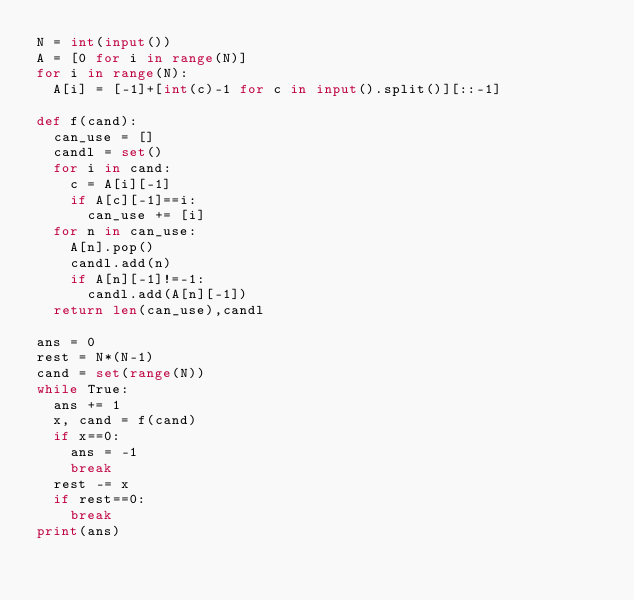<code> <loc_0><loc_0><loc_500><loc_500><_Python_>N = int(input())
A = [0 for i in range(N)]
for i in range(N):
  A[i] = [-1]+[int(c)-1 for c in input().split()][::-1]

def f(cand):
  can_use = []
  candl = set()
  for i in cand:
    c = A[i][-1]
    if A[c][-1]==i:
      can_use += [i]
  for n in can_use:
    A[n].pop()
    candl.add(n)
    if A[n][-1]!=-1:
      candl.add(A[n][-1])
  return len(can_use),candl

ans = 0
rest = N*(N-1)
cand = set(range(N))
while True:
  ans += 1
  x, cand = f(cand)
  if x==0:
    ans = -1
    break
  rest -= x
  if rest==0:
    break
print(ans)</code> 